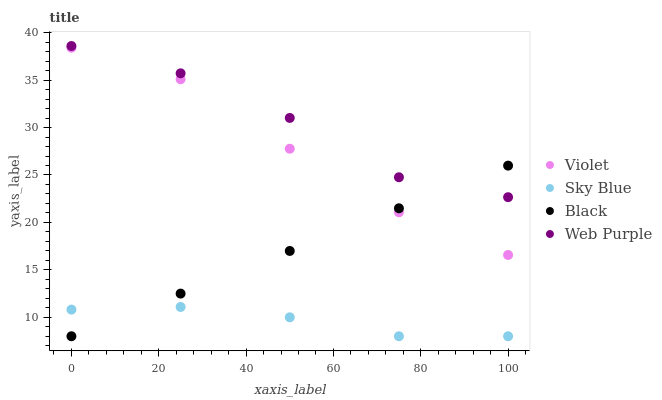Does Sky Blue have the minimum area under the curve?
Answer yes or no. Yes. Does Web Purple have the maximum area under the curve?
Answer yes or no. Yes. Does Black have the minimum area under the curve?
Answer yes or no. No. Does Black have the maximum area under the curve?
Answer yes or no. No. Is Black the smoothest?
Answer yes or no. Yes. Is Web Purple the roughest?
Answer yes or no. Yes. Is Web Purple the smoothest?
Answer yes or no. No. Is Black the roughest?
Answer yes or no. No. Does Sky Blue have the lowest value?
Answer yes or no. Yes. Does Web Purple have the lowest value?
Answer yes or no. No. Does Web Purple have the highest value?
Answer yes or no. Yes. Does Black have the highest value?
Answer yes or no. No. Is Sky Blue less than Web Purple?
Answer yes or no. Yes. Is Web Purple greater than Violet?
Answer yes or no. Yes. Does Sky Blue intersect Black?
Answer yes or no. Yes. Is Sky Blue less than Black?
Answer yes or no. No. Is Sky Blue greater than Black?
Answer yes or no. No. Does Sky Blue intersect Web Purple?
Answer yes or no. No. 